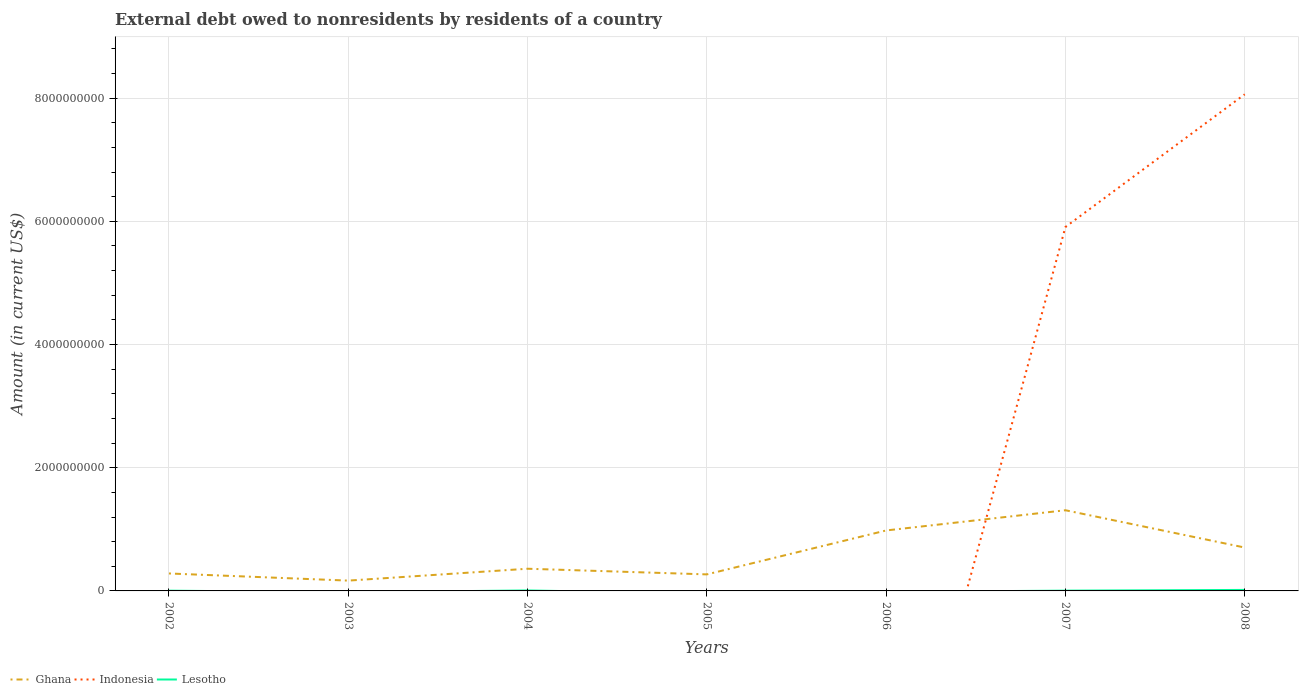Across all years, what is the maximum external debt owed by residents in Indonesia?
Your response must be concise. 0. What is the total external debt owed by residents in Ghana in the graph?
Provide a short and direct response. 9.17e+07. What is the difference between the highest and the second highest external debt owed by residents in Lesotho?
Provide a succinct answer. 1.63e+07. Is the external debt owed by residents in Lesotho strictly greater than the external debt owed by residents in Indonesia over the years?
Ensure brevity in your answer.  No. How many lines are there?
Your answer should be very brief. 3. What is the difference between two consecutive major ticks on the Y-axis?
Provide a short and direct response. 2.00e+09. Does the graph contain grids?
Offer a terse response. Yes. How many legend labels are there?
Keep it short and to the point. 3. What is the title of the graph?
Provide a succinct answer. External debt owed to nonresidents by residents of a country. What is the Amount (in current US$) in Ghana in 2002?
Provide a short and direct response. 2.83e+08. What is the Amount (in current US$) of Lesotho in 2002?
Your answer should be compact. 4.18e+06. What is the Amount (in current US$) in Ghana in 2003?
Give a very brief answer. 1.67e+08. What is the Amount (in current US$) of Lesotho in 2003?
Make the answer very short. 0. What is the Amount (in current US$) in Ghana in 2004?
Give a very brief answer. 3.60e+08. What is the Amount (in current US$) of Indonesia in 2004?
Keep it short and to the point. 0. What is the Amount (in current US$) in Lesotho in 2004?
Your response must be concise. 7.49e+06. What is the Amount (in current US$) of Ghana in 2005?
Provide a succinct answer. 2.68e+08. What is the Amount (in current US$) in Indonesia in 2005?
Keep it short and to the point. 0. What is the Amount (in current US$) in Lesotho in 2005?
Your answer should be very brief. 0. What is the Amount (in current US$) in Ghana in 2006?
Your answer should be compact. 9.81e+08. What is the Amount (in current US$) of Indonesia in 2006?
Provide a short and direct response. 0. What is the Amount (in current US$) in Ghana in 2007?
Your answer should be compact. 1.31e+09. What is the Amount (in current US$) of Indonesia in 2007?
Give a very brief answer. 5.91e+09. What is the Amount (in current US$) of Lesotho in 2007?
Ensure brevity in your answer.  4.50e+06. What is the Amount (in current US$) in Ghana in 2008?
Your response must be concise. 7.04e+08. What is the Amount (in current US$) of Indonesia in 2008?
Your answer should be compact. 8.06e+09. What is the Amount (in current US$) of Lesotho in 2008?
Offer a terse response. 1.63e+07. Across all years, what is the maximum Amount (in current US$) of Ghana?
Offer a very short reply. 1.31e+09. Across all years, what is the maximum Amount (in current US$) of Indonesia?
Provide a short and direct response. 8.06e+09. Across all years, what is the maximum Amount (in current US$) in Lesotho?
Provide a short and direct response. 1.63e+07. Across all years, what is the minimum Amount (in current US$) of Ghana?
Provide a short and direct response. 1.67e+08. What is the total Amount (in current US$) in Ghana in the graph?
Provide a succinct answer. 4.07e+09. What is the total Amount (in current US$) of Indonesia in the graph?
Your answer should be very brief. 1.40e+1. What is the total Amount (in current US$) of Lesotho in the graph?
Offer a terse response. 3.25e+07. What is the difference between the Amount (in current US$) of Ghana in 2002 and that in 2003?
Provide a short and direct response. 1.16e+08. What is the difference between the Amount (in current US$) of Ghana in 2002 and that in 2004?
Give a very brief answer. -7.69e+07. What is the difference between the Amount (in current US$) in Lesotho in 2002 and that in 2004?
Your answer should be very brief. -3.31e+06. What is the difference between the Amount (in current US$) in Ghana in 2002 and that in 2005?
Offer a terse response. 1.49e+07. What is the difference between the Amount (in current US$) in Ghana in 2002 and that in 2006?
Make the answer very short. -6.98e+08. What is the difference between the Amount (in current US$) of Ghana in 2002 and that in 2007?
Your answer should be very brief. -1.03e+09. What is the difference between the Amount (in current US$) in Lesotho in 2002 and that in 2007?
Give a very brief answer. -3.23e+05. What is the difference between the Amount (in current US$) of Ghana in 2002 and that in 2008?
Your response must be concise. -4.21e+08. What is the difference between the Amount (in current US$) in Lesotho in 2002 and that in 2008?
Provide a short and direct response. -1.22e+07. What is the difference between the Amount (in current US$) of Ghana in 2003 and that in 2004?
Your answer should be compact. -1.93e+08. What is the difference between the Amount (in current US$) in Ghana in 2003 and that in 2005?
Give a very brief answer. -1.01e+08. What is the difference between the Amount (in current US$) of Ghana in 2003 and that in 2006?
Your answer should be very brief. -8.14e+08. What is the difference between the Amount (in current US$) in Ghana in 2003 and that in 2007?
Provide a short and direct response. -1.14e+09. What is the difference between the Amount (in current US$) of Ghana in 2003 and that in 2008?
Provide a succinct answer. -5.37e+08. What is the difference between the Amount (in current US$) in Ghana in 2004 and that in 2005?
Ensure brevity in your answer.  9.17e+07. What is the difference between the Amount (in current US$) in Ghana in 2004 and that in 2006?
Provide a succinct answer. -6.21e+08. What is the difference between the Amount (in current US$) of Ghana in 2004 and that in 2007?
Keep it short and to the point. -9.50e+08. What is the difference between the Amount (in current US$) of Lesotho in 2004 and that in 2007?
Offer a terse response. 2.99e+06. What is the difference between the Amount (in current US$) of Ghana in 2004 and that in 2008?
Offer a terse response. -3.44e+08. What is the difference between the Amount (in current US$) of Lesotho in 2004 and that in 2008?
Your answer should be compact. -8.85e+06. What is the difference between the Amount (in current US$) in Ghana in 2005 and that in 2006?
Offer a very short reply. -7.13e+08. What is the difference between the Amount (in current US$) in Ghana in 2005 and that in 2007?
Your answer should be very brief. -1.04e+09. What is the difference between the Amount (in current US$) of Ghana in 2005 and that in 2008?
Give a very brief answer. -4.36e+08. What is the difference between the Amount (in current US$) in Ghana in 2006 and that in 2007?
Your response must be concise. -3.28e+08. What is the difference between the Amount (in current US$) in Ghana in 2006 and that in 2008?
Ensure brevity in your answer.  2.77e+08. What is the difference between the Amount (in current US$) in Ghana in 2007 and that in 2008?
Your answer should be compact. 6.05e+08. What is the difference between the Amount (in current US$) in Indonesia in 2007 and that in 2008?
Keep it short and to the point. -2.15e+09. What is the difference between the Amount (in current US$) of Lesotho in 2007 and that in 2008?
Your answer should be compact. -1.18e+07. What is the difference between the Amount (in current US$) in Ghana in 2002 and the Amount (in current US$) in Lesotho in 2004?
Ensure brevity in your answer.  2.76e+08. What is the difference between the Amount (in current US$) in Ghana in 2002 and the Amount (in current US$) in Indonesia in 2007?
Provide a short and direct response. -5.62e+09. What is the difference between the Amount (in current US$) in Ghana in 2002 and the Amount (in current US$) in Lesotho in 2007?
Provide a short and direct response. 2.79e+08. What is the difference between the Amount (in current US$) of Ghana in 2002 and the Amount (in current US$) of Indonesia in 2008?
Offer a terse response. -7.78e+09. What is the difference between the Amount (in current US$) of Ghana in 2002 and the Amount (in current US$) of Lesotho in 2008?
Ensure brevity in your answer.  2.67e+08. What is the difference between the Amount (in current US$) of Ghana in 2003 and the Amount (in current US$) of Lesotho in 2004?
Offer a very short reply. 1.60e+08. What is the difference between the Amount (in current US$) in Ghana in 2003 and the Amount (in current US$) in Indonesia in 2007?
Give a very brief answer. -5.74e+09. What is the difference between the Amount (in current US$) in Ghana in 2003 and the Amount (in current US$) in Lesotho in 2007?
Your answer should be very brief. 1.63e+08. What is the difference between the Amount (in current US$) of Ghana in 2003 and the Amount (in current US$) of Indonesia in 2008?
Provide a succinct answer. -7.89e+09. What is the difference between the Amount (in current US$) in Ghana in 2003 and the Amount (in current US$) in Lesotho in 2008?
Offer a very short reply. 1.51e+08. What is the difference between the Amount (in current US$) in Ghana in 2004 and the Amount (in current US$) in Indonesia in 2007?
Keep it short and to the point. -5.55e+09. What is the difference between the Amount (in current US$) of Ghana in 2004 and the Amount (in current US$) of Lesotho in 2007?
Make the answer very short. 3.56e+08. What is the difference between the Amount (in current US$) in Ghana in 2004 and the Amount (in current US$) in Indonesia in 2008?
Make the answer very short. -7.70e+09. What is the difference between the Amount (in current US$) of Ghana in 2004 and the Amount (in current US$) of Lesotho in 2008?
Give a very brief answer. 3.44e+08. What is the difference between the Amount (in current US$) in Ghana in 2005 and the Amount (in current US$) in Indonesia in 2007?
Give a very brief answer. -5.64e+09. What is the difference between the Amount (in current US$) of Ghana in 2005 and the Amount (in current US$) of Lesotho in 2007?
Offer a terse response. 2.64e+08. What is the difference between the Amount (in current US$) of Ghana in 2005 and the Amount (in current US$) of Indonesia in 2008?
Offer a terse response. -7.79e+09. What is the difference between the Amount (in current US$) of Ghana in 2005 and the Amount (in current US$) of Lesotho in 2008?
Provide a short and direct response. 2.52e+08. What is the difference between the Amount (in current US$) in Ghana in 2006 and the Amount (in current US$) in Indonesia in 2007?
Your answer should be compact. -4.93e+09. What is the difference between the Amount (in current US$) in Ghana in 2006 and the Amount (in current US$) in Lesotho in 2007?
Offer a very short reply. 9.77e+08. What is the difference between the Amount (in current US$) of Ghana in 2006 and the Amount (in current US$) of Indonesia in 2008?
Provide a short and direct response. -7.08e+09. What is the difference between the Amount (in current US$) of Ghana in 2006 and the Amount (in current US$) of Lesotho in 2008?
Offer a very short reply. 9.65e+08. What is the difference between the Amount (in current US$) in Ghana in 2007 and the Amount (in current US$) in Indonesia in 2008?
Make the answer very short. -6.75e+09. What is the difference between the Amount (in current US$) of Ghana in 2007 and the Amount (in current US$) of Lesotho in 2008?
Your answer should be very brief. 1.29e+09. What is the difference between the Amount (in current US$) of Indonesia in 2007 and the Amount (in current US$) of Lesotho in 2008?
Your answer should be compact. 5.89e+09. What is the average Amount (in current US$) of Ghana per year?
Offer a terse response. 5.82e+08. What is the average Amount (in current US$) in Indonesia per year?
Make the answer very short. 2.00e+09. What is the average Amount (in current US$) in Lesotho per year?
Your answer should be very brief. 4.64e+06. In the year 2002, what is the difference between the Amount (in current US$) in Ghana and Amount (in current US$) in Lesotho?
Keep it short and to the point. 2.79e+08. In the year 2004, what is the difference between the Amount (in current US$) in Ghana and Amount (in current US$) in Lesotho?
Offer a very short reply. 3.53e+08. In the year 2007, what is the difference between the Amount (in current US$) in Ghana and Amount (in current US$) in Indonesia?
Make the answer very short. -4.60e+09. In the year 2007, what is the difference between the Amount (in current US$) of Ghana and Amount (in current US$) of Lesotho?
Keep it short and to the point. 1.31e+09. In the year 2007, what is the difference between the Amount (in current US$) of Indonesia and Amount (in current US$) of Lesotho?
Your answer should be very brief. 5.90e+09. In the year 2008, what is the difference between the Amount (in current US$) of Ghana and Amount (in current US$) of Indonesia?
Your answer should be compact. -7.36e+09. In the year 2008, what is the difference between the Amount (in current US$) of Ghana and Amount (in current US$) of Lesotho?
Your answer should be compact. 6.88e+08. In the year 2008, what is the difference between the Amount (in current US$) of Indonesia and Amount (in current US$) of Lesotho?
Your answer should be compact. 8.05e+09. What is the ratio of the Amount (in current US$) of Ghana in 2002 to that in 2003?
Ensure brevity in your answer.  1.69. What is the ratio of the Amount (in current US$) in Ghana in 2002 to that in 2004?
Make the answer very short. 0.79. What is the ratio of the Amount (in current US$) in Lesotho in 2002 to that in 2004?
Your answer should be very brief. 0.56. What is the ratio of the Amount (in current US$) of Ghana in 2002 to that in 2005?
Your answer should be very brief. 1.06. What is the ratio of the Amount (in current US$) of Ghana in 2002 to that in 2006?
Your answer should be very brief. 0.29. What is the ratio of the Amount (in current US$) of Ghana in 2002 to that in 2007?
Your response must be concise. 0.22. What is the ratio of the Amount (in current US$) in Lesotho in 2002 to that in 2007?
Your answer should be compact. 0.93. What is the ratio of the Amount (in current US$) of Ghana in 2002 to that in 2008?
Your response must be concise. 0.4. What is the ratio of the Amount (in current US$) of Lesotho in 2002 to that in 2008?
Provide a short and direct response. 0.26. What is the ratio of the Amount (in current US$) in Ghana in 2003 to that in 2004?
Offer a very short reply. 0.46. What is the ratio of the Amount (in current US$) of Ghana in 2003 to that in 2005?
Ensure brevity in your answer.  0.62. What is the ratio of the Amount (in current US$) of Ghana in 2003 to that in 2006?
Your answer should be very brief. 0.17. What is the ratio of the Amount (in current US$) of Ghana in 2003 to that in 2007?
Offer a terse response. 0.13. What is the ratio of the Amount (in current US$) of Ghana in 2003 to that in 2008?
Your response must be concise. 0.24. What is the ratio of the Amount (in current US$) in Ghana in 2004 to that in 2005?
Provide a succinct answer. 1.34. What is the ratio of the Amount (in current US$) of Ghana in 2004 to that in 2006?
Offer a terse response. 0.37. What is the ratio of the Amount (in current US$) in Ghana in 2004 to that in 2007?
Give a very brief answer. 0.28. What is the ratio of the Amount (in current US$) in Lesotho in 2004 to that in 2007?
Your answer should be very brief. 1.67. What is the ratio of the Amount (in current US$) in Ghana in 2004 to that in 2008?
Make the answer very short. 0.51. What is the ratio of the Amount (in current US$) of Lesotho in 2004 to that in 2008?
Give a very brief answer. 0.46. What is the ratio of the Amount (in current US$) in Ghana in 2005 to that in 2006?
Make the answer very short. 0.27. What is the ratio of the Amount (in current US$) in Ghana in 2005 to that in 2007?
Your response must be concise. 0.2. What is the ratio of the Amount (in current US$) in Ghana in 2005 to that in 2008?
Provide a succinct answer. 0.38. What is the ratio of the Amount (in current US$) in Ghana in 2006 to that in 2007?
Give a very brief answer. 0.75. What is the ratio of the Amount (in current US$) of Ghana in 2006 to that in 2008?
Give a very brief answer. 1.39. What is the ratio of the Amount (in current US$) of Ghana in 2007 to that in 2008?
Your response must be concise. 1.86. What is the ratio of the Amount (in current US$) of Indonesia in 2007 to that in 2008?
Your response must be concise. 0.73. What is the ratio of the Amount (in current US$) of Lesotho in 2007 to that in 2008?
Your response must be concise. 0.28. What is the difference between the highest and the second highest Amount (in current US$) of Ghana?
Give a very brief answer. 3.28e+08. What is the difference between the highest and the second highest Amount (in current US$) of Lesotho?
Your answer should be compact. 8.85e+06. What is the difference between the highest and the lowest Amount (in current US$) in Ghana?
Your response must be concise. 1.14e+09. What is the difference between the highest and the lowest Amount (in current US$) of Indonesia?
Give a very brief answer. 8.06e+09. What is the difference between the highest and the lowest Amount (in current US$) in Lesotho?
Your answer should be very brief. 1.63e+07. 